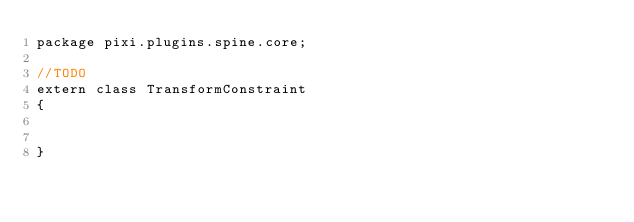Convert code to text. <code><loc_0><loc_0><loc_500><loc_500><_Haxe_>package pixi.plugins.spine.core;

//TODO
extern class TransformConstraint 
{

	
}</code> 